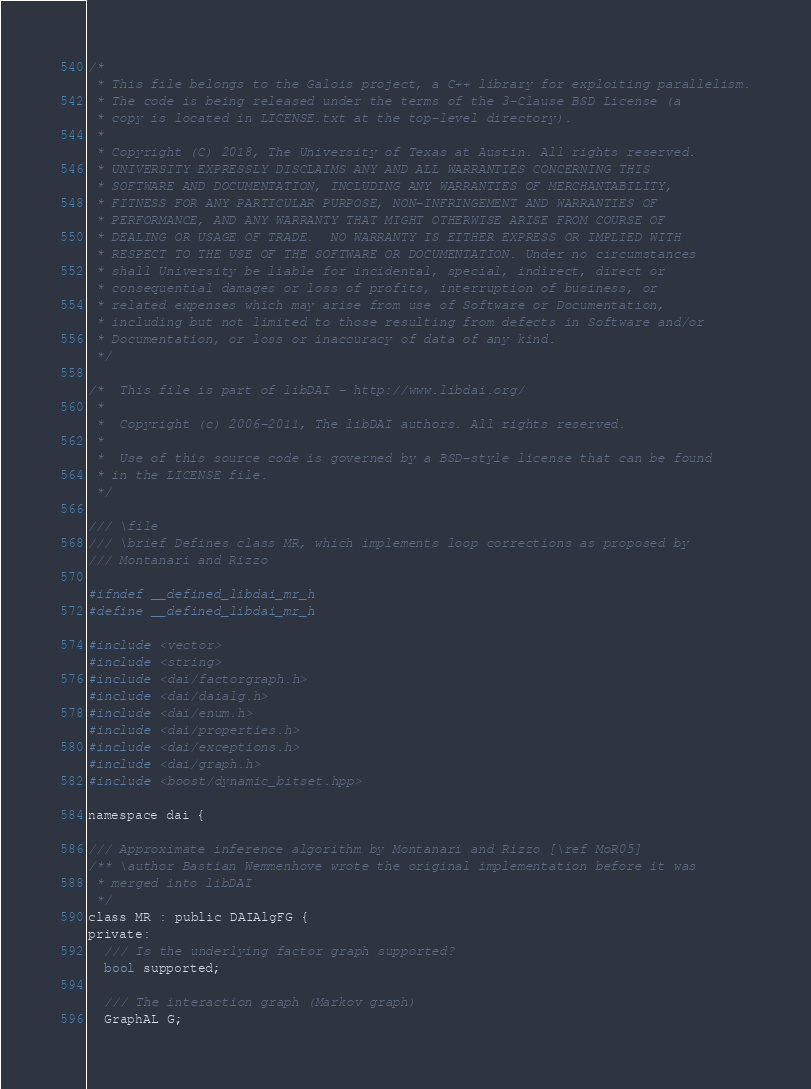Convert code to text. <code><loc_0><loc_0><loc_500><loc_500><_C_>/*
 * This file belongs to the Galois project, a C++ library for exploiting parallelism.
 * The code is being released under the terms of the 3-Clause BSD License (a
 * copy is located in LICENSE.txt at the top-level directory).
 *
 * Copyright (C) 2018, The University of Texas at Austin. All rights reserved.
 * UNIVERSITY EXPRESSLY DISCLAIMS ANY AND ALL WARRANTIES CONCERNING THIS
 * SOFTWARE AND DOCUMENTATION, INCLUDING ANY WARRANTIES OF MERCHANTABILITY,
 * FITNESS FOR ANY PARTICULAR PURPOSE, NON-INFRINGEMENT AND WARRANTIES OF
 * PERFORMANCE, AND ANY WARRANTY THAT MIGHT OTHERWISE ARISE FROM COURSE OF
 * DEALING OR USAGE OF TRADE.  NO WARRANTY IS EITHER EXPRESS OR IMPLIED WITH
 * RESPECT TO THE USE OF THE SOFTWARE OR DOCUMENTATION. Under no circumstances
 * shall University be liable for incidental, special, indirect, direct or
 * consequential damages or loss of profits, interruption of business, or
 * related expenses which may arise from use of Software or Documentation,
 * including but not limited to those resulting from defects in Software and/or
 * Documentation, or loss or inaccuracy of data of any kind.
 */

/*  This file is part of libDAI - http://www.libdai.org/
 *
 *  Copyright (c) 2006-2011, The libDAI authors. All rights reserved.
 *
 *  Use of this source code is governed by a BSD-style license that can be found
 * in the LICENSE file.
 */

/// \file
/// \brief Defines class MR, which implements loop corrections as proposed by
/// Montanari and Rizzo

#ifndef __defined_libdai_mr_h
#define __defined_libdai_mr_h

#include <vector>
#include <string>
#include <dai/factorgraph.h>
#include <dai/daialg.h>
#include <dai/enum.h>
#include <dai/properties.h>
#include <dai/exceptions.h>
#include <dai/graph.h>
#include <boost/dynamic_bitset.hpp>

namespace dai {

/// Approximate inference algorithm by Montanari and Rizzo [\ref MoR05]
/** \author Bastian Wemmenhove wrote the original implementation before it was
 * merged into libDAI
 */
class MR : public DAIAlgFG {
private:
  /// Is the underlying factor graph supported?
  bool supported;

  /// The interaction graph (Markov graph)
  GraphAL G;
</code> 